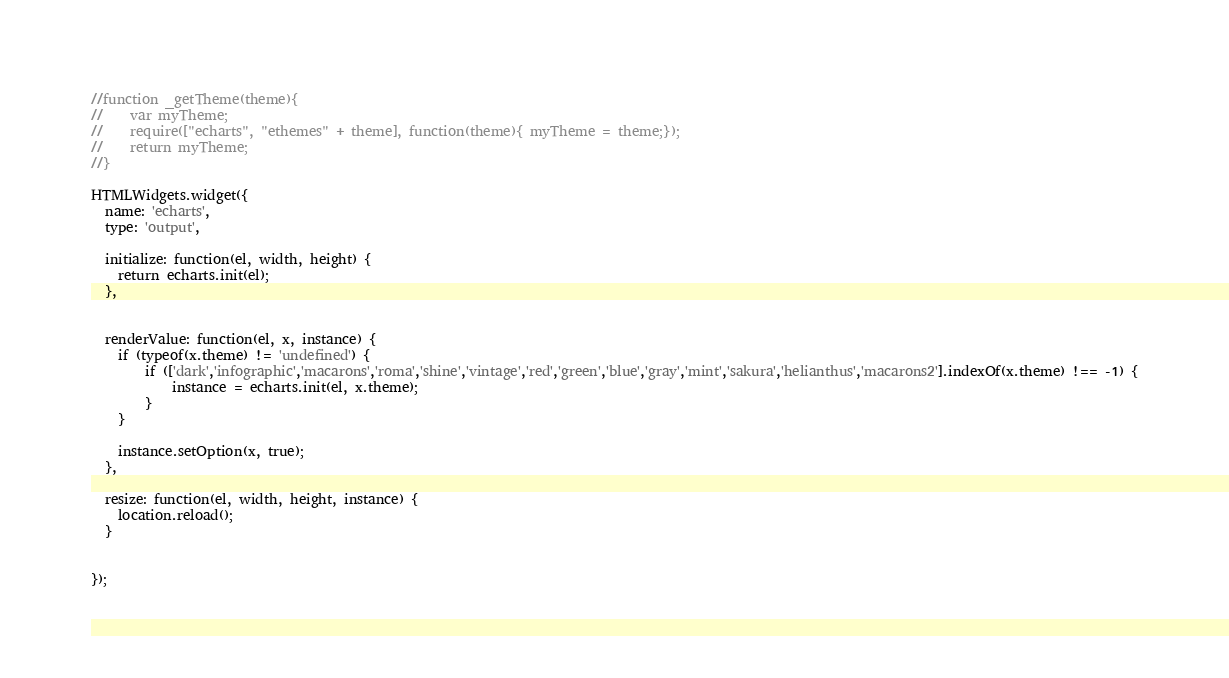Convert code to text. <code><loc_0><loc_0><loc_500><loc_500><_JavaScript_>//function _getTheme(theme){
//    var myTheme;
//    require(["echarts", "ethemes" + theme], function(theme){ myTheme = theme;});
//    return myTheme;
//}

HTMLWidgets.widget({
  name: 'echarts',
  type: 'output',

  initialize: function(el, width, height) {
    return echarts.init(el);
  },


  renderValue: function(el, x, instance) {
    if (typeof(x.theme) != 'undefined') {
		if (['dark','infographic','macarons','roma','shine','vintage','red','green','blue','gray','mint','sakura','helianthus','macarons2'].indexOf(x.theme) !== -1) {
			instance = echarts.init(el, x.theme);
		}
	}

	instance.setOption(x, true);
  },

  resize: function(el, width, height, instance) {
    location.reload();
  }


});
</code> 